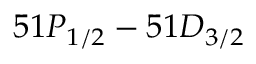<formula> <loc_0><loc_0><loc_500><loc_500>5 1 P _ { 1 / 2 } - 5 1 D _ { 3 / 2 }</formula> 